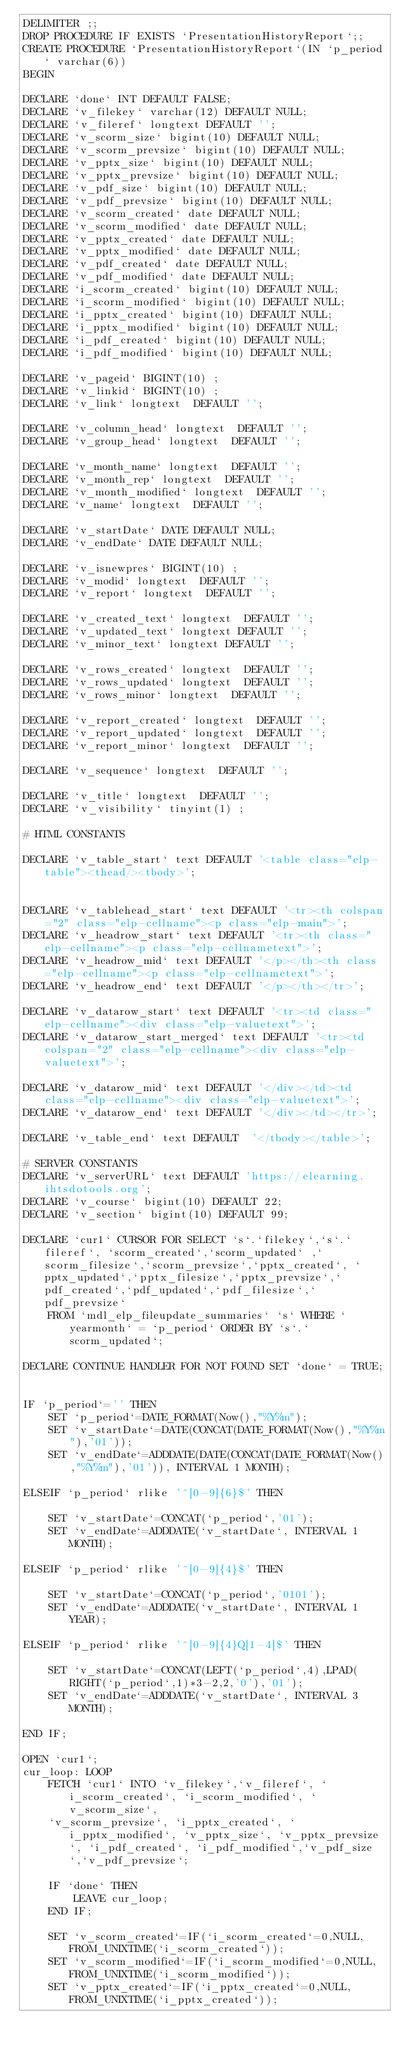Convert code to text. <code><loc_0><loc_0><loc_500><loc_500><_SQL_>DELIMITER ;;
DROP PROCEDURE IF EXISTS `PresentationHistoryReport`;;
CREATE PROCEDURE `PresentationHistoryReport`(IN `p_period` varchar(6))
BEGIN

DECLARE `done` INT DEFAULT FALSE;
DECLARE `v_filekey` varchar(12) DEFAULT NULL;
DECLARE `v_fileref` longtext DEFAULT '';
DECLARE `v_scorm_size` bigint(10) DEFAULT NULL;
DECLARE `v_scorm_prevsize` bigint(10) DEFAULT NULL;
DECLARE `v_pptx_size` bigint(10) DEFAULT NULL;
DECLARE `v_pptx_prevsize` bigint(10) DEFAULT NULL;
DECLARE `v_pdf_size` bigint(10) DEFAULT NULL;
DECLARE `v_pdf_prevsize` bigint(10) DEFAULT NULL;
DECLARE `v_scorm_created` date DEFAULT NULL;
DECLARE `v_scorm_modified` date DEFAULT NULL;
DECLARE `v_pptx_created` date DEFAULT NULL;
DECLARE `v_pptx_modified` date DEFAULT NULL;
DECLARE `v_pdf_created` date DEFAULT NULL;
DECLARE `v_pdf_modified` date DEFAULT NULL;
DECLARE `i_scorm_created` bigint(10) DEFAULT NULL;
DECLARE `i_scorm_modified` bigint(10) DEFAULT NULL;
DECLARE `i_pptx_created` bigint(10) DEFAULT NULL;
DECLARE `i_pptx_modified` bigint(10) DEFAULT NULL;
DECLARE `i_pdf_created` bigint(10) DEFAULT NULL;
DECLARE `i_pdf_modified` bigint(10) DEFAULT NULL;

DECLARE `v_pageid` BIGINT(10) ;
DECLARE `v_linkid` BIGINT(10) ;
DECLARE `v_link` longtext  DEFAULT '';

DECLARE `v_column_head` longtext  DEFAULT '';
DECLARE `v_group_head` longtext  DEFAULT '';

DECLARE `v_month_name` longtext  DEFAULT '';
DECLARE `v_month_rep` longtext  DEFAULT '';
DECLARE `v_month_modified` longtext  DEFAULT '';
DECLARE `v_name` longtext  DEFAULT '';

DECLARE `v_startDate` DATE DEFAULT NULL;
DECLARE `v_endDate` DATE DEFAULT NULL;

DECLARE `v_isnewpres` BIGINT(10) ;
DECLARE `v_modid` longtext  DEFAULT '';
DECLARE `v_report` longtext  DEFAULT '';

DECLARE `v_created_text` longtext  DEFAULT '';
DECLARE `v_updated_text` longtext DEFAULT '';
DECLARE `v_minor_text` longtext DEFAULT '';

DECLARE `v_rows_created` longtext  DEFAULT '';
DECLARE `v_rows_updated` longtext  DEFAULT '';
DECLARE `v_rows_minor` longtext  DEFAULT '';

DECLARE `v_report_created` longtext  DEFAULT '';
DECLARE `v_report_updated` longtext  DEFAULT '';
DECLARE `v_report_minor` longtext  DEFAULT '';

DECLARE `v_sequence` longtext  DEFAULT '';

DECLARE `v_title` longtext  DEFAULT '';
DECLARE `v_visibility` tinyint(1) ;

# HTML CONSTANTS

DECLARE `v_table_start` text DEFAULT '<table class="elp-table"><thead/><tbody>';


DECLARE `v_tablehead_start` text DEFAULT '<tr><th colspan="2" class="elp-cellname"><p class="elp-main">';
DECLARE `v_headrow_start` text DEFAULT '<tr><th class="elp-cellname"><p class="elp-cellnametext">';
DECLARE `v_headrow_mid` text DEFAULT '</p></th><th class="elp-cellname"><p class="elp-cellnametext">';
DECLARE `v_headrow_end` text DEFAULT '</p></th></tr>';

DECLARE `v_datarow_start` text DEFAULT '<tr><td class="elp-cellname"><div class="elp-valuetext">';
DECLARE `v_datarow_start_merged` text DEFAULT '<tr><td colspan="2" class="elp-cellname"><div class="elp-valuetext">';

DECLARE `v_datarow_mid` text DEFAULT '</div></td><td class="elp-cellname"><div class="elp-valuetext">';
DECLARE `v_datarow_end` text DEFAULT '</div></td></tr>';

DECLARE `v_table_end` text DEFAULT  '</tbody></table>';

# SERVER CONSTANTS
DECLARE `v_serverURL` text DEFAULT 'https://elearning.ihtsdotools.org';
DECLARE `v_course` bigint(10) DEFAULT 22;
DECLARE `v_section` bigint(10) DEFAULT 99; 

DECLARE `cur1` CURSOR FOR SELECT `s`.`filekey`,`s`.`fileref`, `scorm_created`,`scorm_updated` ,`scorm_filesize`,`scorm_prevsize`,`pptx_created`, `pptx_updated`,`pptx_filesize`,`pptx_prevsize`,`pdf_created`,`pdf_updated`,`pdf_filesize`,`pdf_prevsize`
	FROM `mdl_elp_fileupdate_summaries` `s` WHERE `yearmonth` = `p_period` ORDER BY `s`.`scorm_updated`;

DECLARE CONTINUE HANDLER FOR NOT FOUND SET `done` = TRUE;


IF `p_period`='' THEN
	SET `p_period`=DATE_FORMAT(Now(),"%Y%m");
	SET `v_startDate`=DATE(CONCAT(DATE_FORMAT(Now(),"%Y%m"),'01'));
	SET `v_endDate`=ADDDATE(DATE(CONCAT(DATE_FORMAT(Now(),"%Y%m"),'01')), INTERVAL 1 MONTH);

ELSEIF `p_period` rlike '^[0-9]{6}$' THEN
	
	SET `v_startDate`=CONCAT(`p_period`,'01');
	SET `v_endDate`=ADDDATE(`v_startDate`, INTERVAL 1 MONTH);

ELSEIF `p_period` rlike '^[0-9]{4}$' THEN
	
	SET `v_startDate`=CONCAT(`p_period`,'0101');
	SET `v_endDate`=ADDDATE(`v_startDate`, INTERVAL 1 YEAR);

ELSEIF `p_period` rlike '^[0-9]{4}Q[1-4]$' THEN
	
	SET `v_startDate`=CONCAT(LEFT(`p_period`,4),LPAD(RIGHT(`p_period`,1)*3-2,2,'0'),'01');
	SET `v_endDate`=ADDDATE(`v_startDate`, INTERVAL 3 MONTH);

END IF;

OPEN `cur1`;
cur_loop: LOOP
	FETCH `cur1` INTO `v_filekey`,`v_fileref`, `i_scorm_created`, `i_scorm_modified`, `v_scorm_size`, 
	`v_scorm_prevsize`, `i_pptx_created`, `i_pptx_modified`, `v_pptx_size`, `v_pptx_prevsize`, `i_pdf_created`, `i_pdf_modified`,`v_pdf_size`,`v_pdf_prevsize`;	
	
	IF `done` THEN
		LEAVE cur_loop;
	END IF;
	
	SET `v_scorm_created`=IF(`i_scorm_created`=0,NULL,FROM_UNIXTIME(`i_scorm_created`));
	SET `v_scorm_modified`=IF(`i_scorm_modified`=0,NULL,FROM_UNIXTIME(`i_scorm_modified`));
	SET `v_pptx_created`=IF(`i_pptx_created`=0,NULL,FROM_UNIXTIME(`i_pptx_created`));</code> 